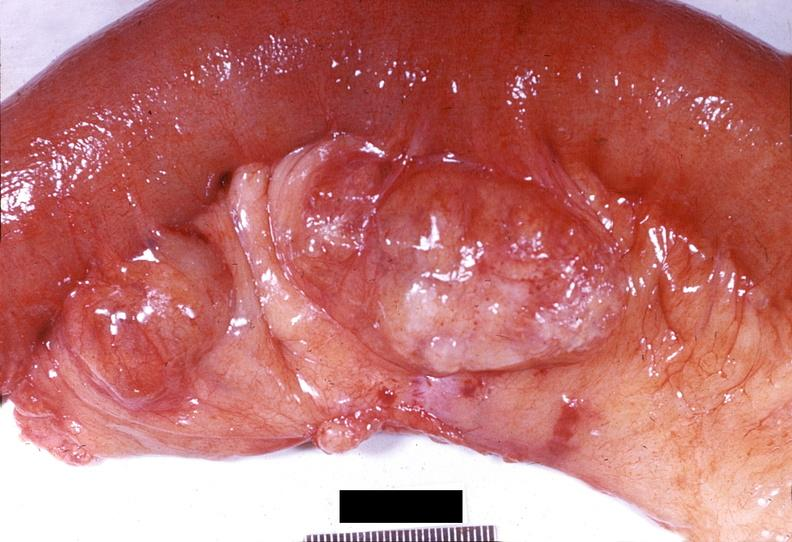s gastrointestinal present?
Answer the question using a single word or phrase. Yes 